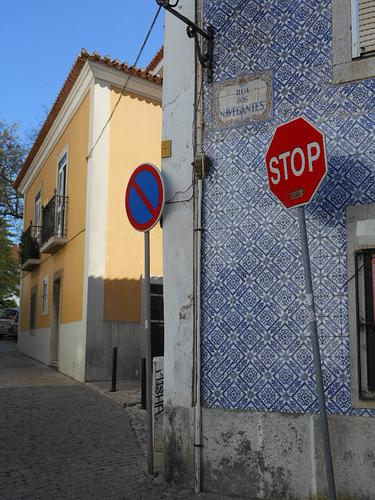Question: what is on the sign?
Choices:
A. Go.
B. Caution.
C. Stop.
D. Yield.
Answer with the letter. Answer: C Question: what are the signs?
Choices:
A. Billboards.
B. Speed Limits.
C. Warnings.
D. Crossings.
Answer with the letter. Answer: C Question: where are the signs?
Choices:
A. Across the street.
B. Next to building.
C. In front of the building.
D. Behind the building.
Answer with the letter. Answer: B Question: why are they the signs there?
Choices:
A. Greetings.
B. Farewells.
C. Apologies.
D. Warnings.
Answer with the letter. Answer: D 